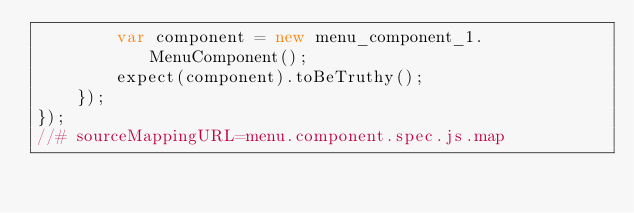Convert code to text. <code><loc_0><loc_0><loc_500><loc_500><_JavaScript_>        var component = new menu_component_1.MenuComponent();
        expect(component).toBeTruthy();
    });
});
//# sourceMappingURL=menu.component.spec.js.map</code> 